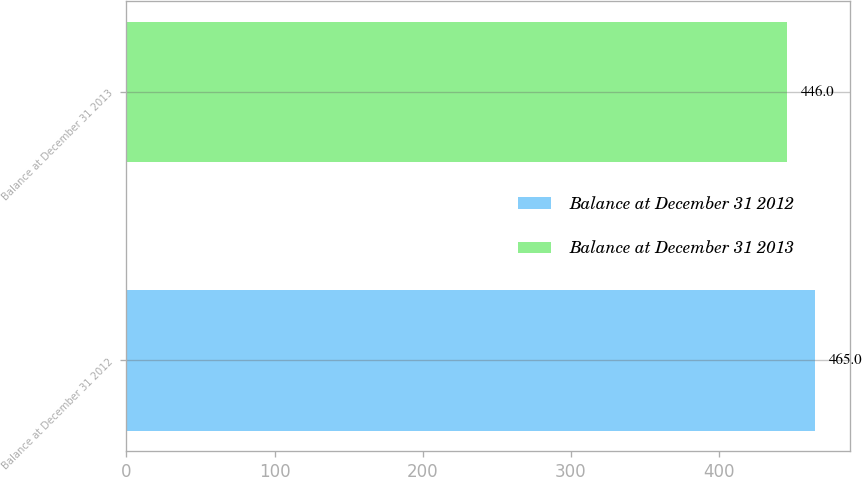<chart> <loc_0><loc_0><loc_500><loc_500><bar_chart><fcel>Balance at December 31 2012<fcel>Balance at December 31 2013<nl><fcel>465<fcel>446<nl></chart> 